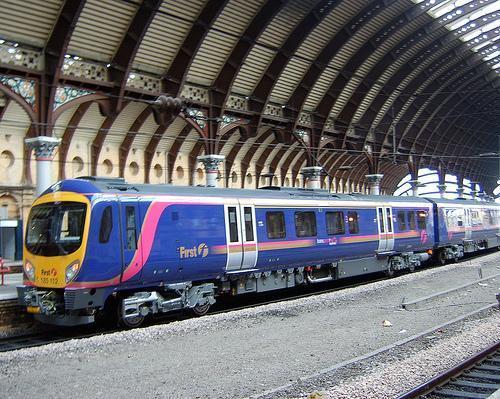How many trains are shown?
Give a very brief answer. 1. How many tracks are shown?
Give a very brief answer. 2. 